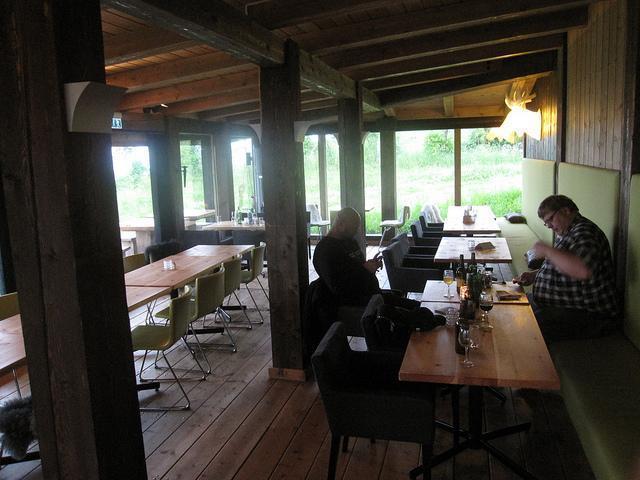What kind of shirt is the heavier man wearing?
Answer the question by selecting the correct answer among the 4 following choices.
Options: None, red, checkered, long sleeve. Checkered. 